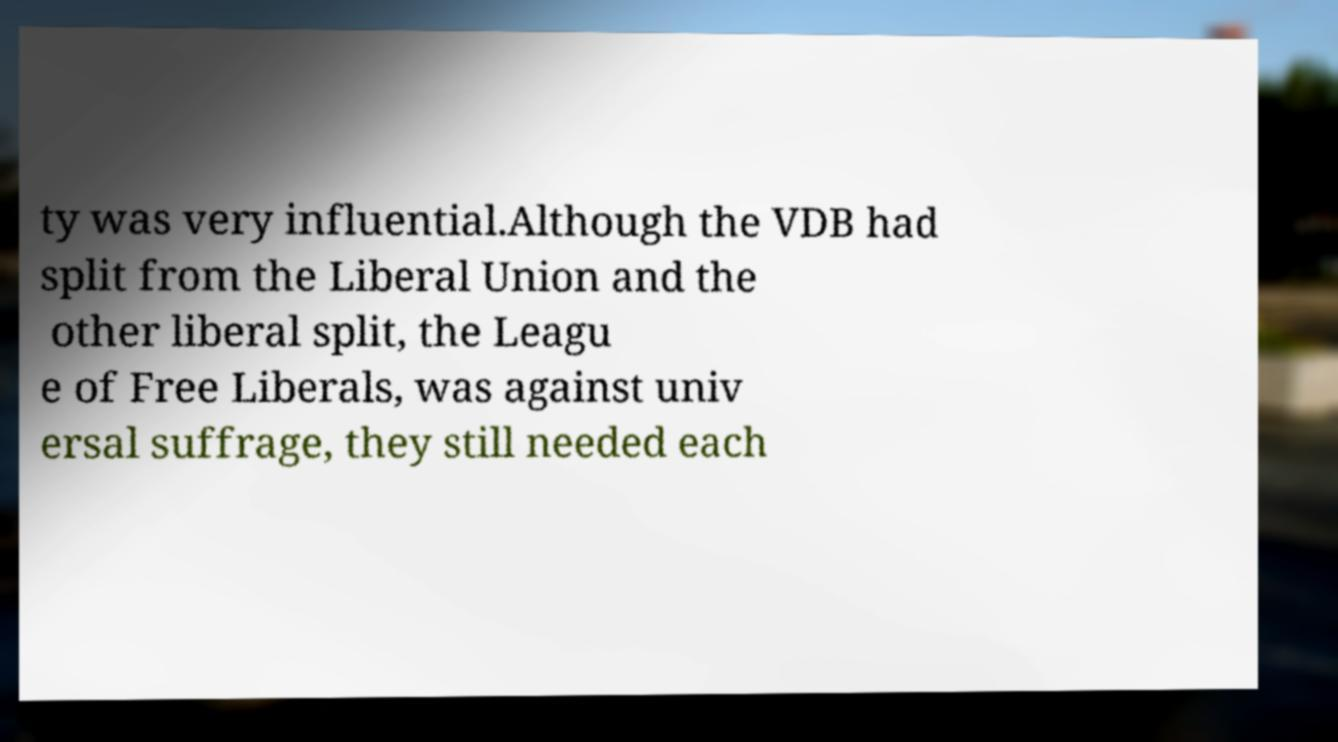For documentation purposes, I need the text within this image transcribed. Could you provide that? ty was very influential.Although the VDB had split from the Liberal Union and the other liberal split, the Leagu e of Free Liberals, was against univ ersal suffrage, they still needed each 